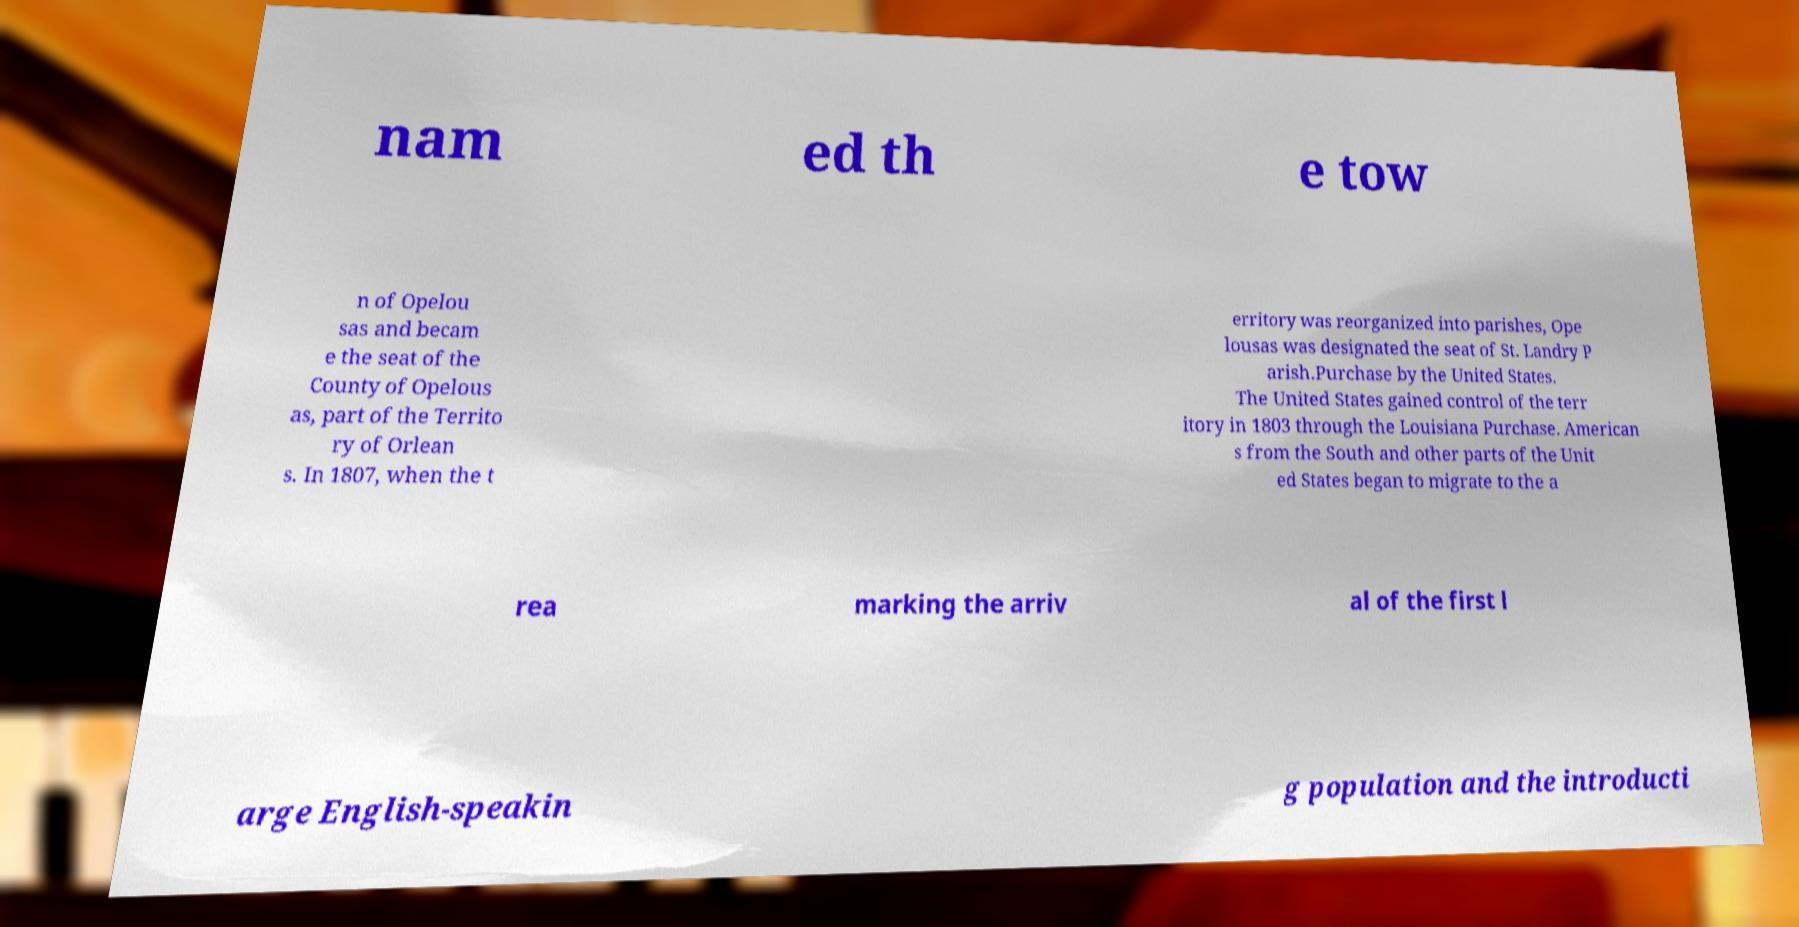Could you assist in decoding the text presented in this image and type it out clearly? nam ed th e tow n of Opelou sas and becam e the seat of the County of Opelous as, part of the Territo ry of Orlean s. In 1807, when the t erritory was reorganized into parishes, Ope lousas was designated the seat of St. Landry P arish.Purchase by the United States. The United States gained control of the terr itory in 1803 through the Louisiana Purchase. American s from the South and other parts of the Unit ed States began to migrate to the a rea marking the arriv al of the first l arge English-speakin g population and the introducti 